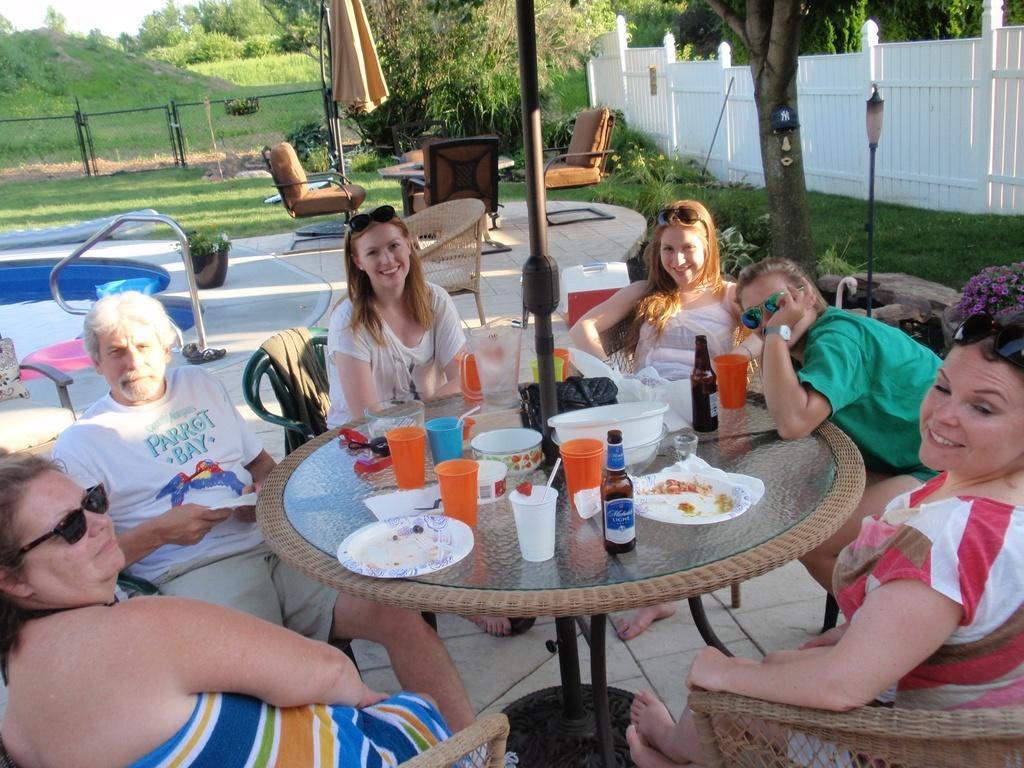How would you summarize this image in a sentence or two? This image is clicked in a garden. There are six persons in this image. They are sitting in front of a table. On which, there are bottles, glasses, bowls and plates. To the right, the woman is sitting in a chair and wearing a red and white dress. In the background there is fencing, grass, trees. To the left there is a swimming pool. To the right there is a tree and a light pole. 